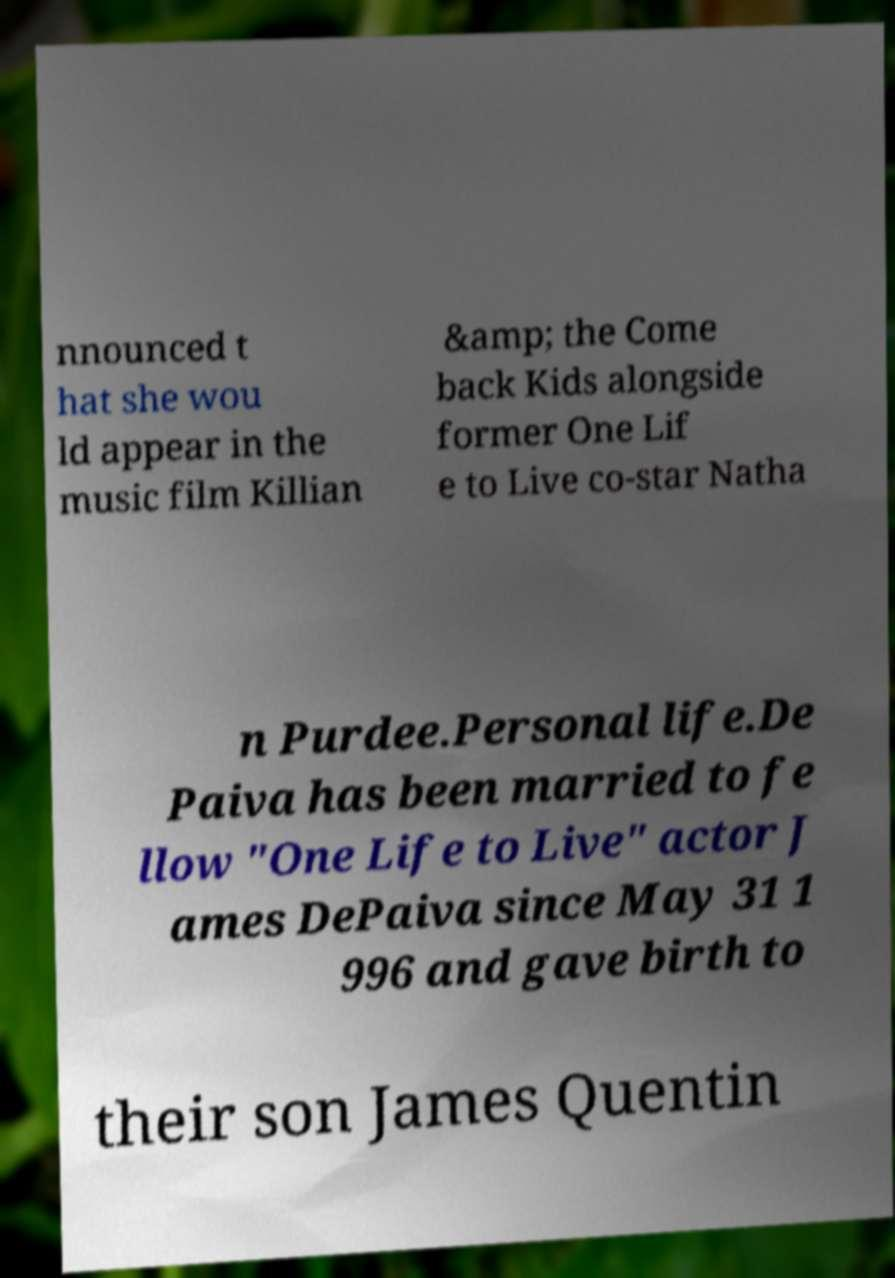Could you assist in decoding the text presented in this image and type it out clearly? nnounced t hat she wou ld appear in the music film Killian &amp; the Come back Kids alongside former One Lif e to Live co-star Natha n Purdee.Personal life.De Paiva has been married to fe llow "One Life to Live" actor J ames DePaiva since May 31 1 996 and gave birth to their son James Quentin 